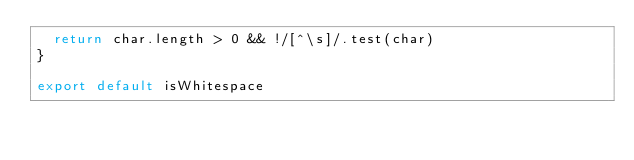Convert code to text. <code><loc_0><loc_0><loc_500><loc_500><_JavaScript_>  return char.length > 0 && !/[^\s]/.test(char)
}

export default isWhitespace
</code> 